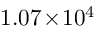Convert formula to latex. <formula><loc_0><loc_0><loc_500><loc_500>1 . 0 7 \, \times \, 1 0 ^ { 4 }</formula> 